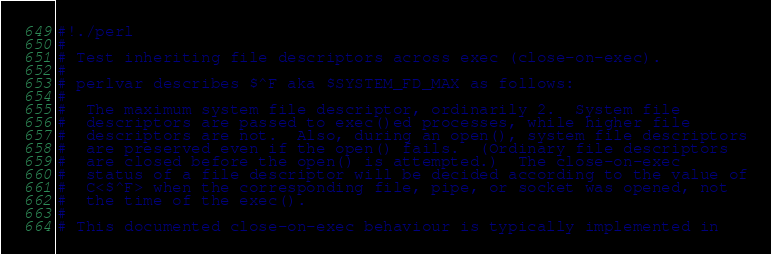<code> <loc_0><loc_0><loc_500><loc_500><_Perl_>#!./perl
#
# Test inheriting file descriptors across exec (close-on-exec).
#
# perlvar describes $^F aka $SYSTEM_FD_MAX as follows:
#
#  The maximum system file descriptor, ordinarily 2.  System file
#  descriptors are passed to exec()ed processes, while higher file
#  descriptors are not.  Also, during an open(), system file descriptors
#  are preserved even if the open() fails.  (Ordinary file descriptors
#  are closed before the open() is attempted.)  The close-on-exec
#  status of a file descriptor will be decided according to the value of
#  C<$^F> when the corresponding file, pipe, or socket was opened, not
#  the time of the exec().
#
# This documented close-on-exec behaviour is typically implemented in</code> 